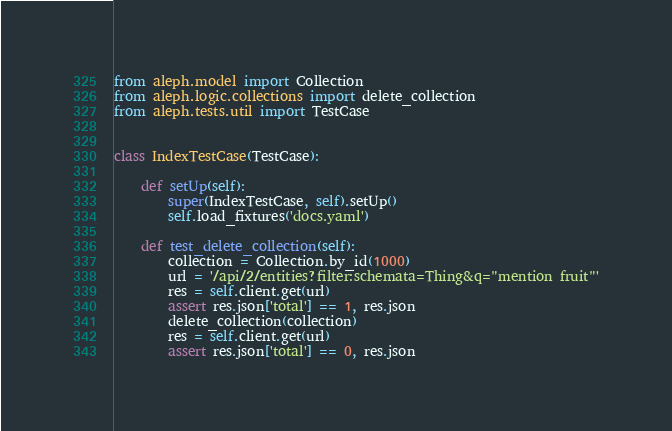<code> <loc_0><loc_0><loc_500><loc_500><_Python_>from aleph.model import Collection
from aleph.logic.collections import delete_collection
from aleph.tests.util import TestCase


class IndexTestCase(TestCase):

    def setUp(self):
        super(IndexTestCase, self).setUp()
        self.load_fixtures('docs.yaml')

    def test_delete_collection(self):
        collection = Collection.by_id(1000)
        url = '/api/2/entities?filter:schemata=Thing&q="mention fruit"'
        res = self.client.get(url)
        assert res.json['total'] == 1, res.json
        delete_collection(collection)
        res = self.client.get(url)
        assert res.json['total'] == 0, res.json
</code> 